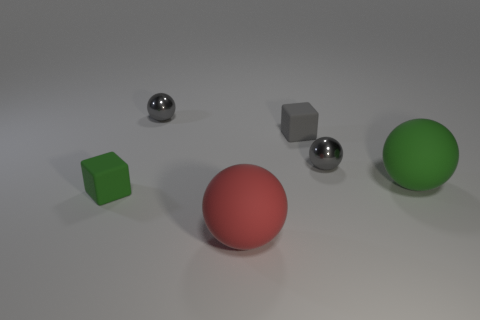Subtract 1 spheres. How many spheres are left? 3 Subtract all green balls. How many balls are left? 3 Add 2 gray metal spheres. How many objects exist? 8 Subtract all cyan balls. Subtract all blue cylinders. How many balls are left? 4 Subtract all balls. How many objects are left? 2 Subtract all green objects. Subtract all large green rubber things. How many objects are left? 3 Add 2 small rubber things. How many small rubber things are left? 4 Add 2 brown cylinders. How many brown cylinders exist? 2 Subtract 0 yellow balls. How many objects are left? 6 